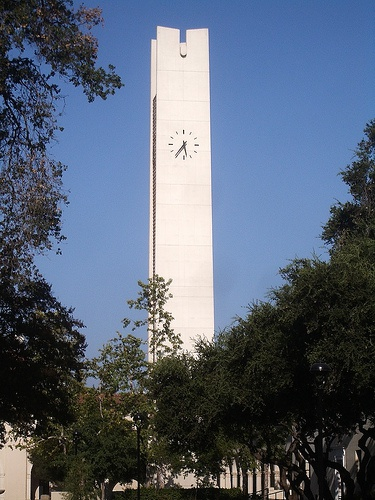Describe the objects in this image and their specific colors. I can see a clock in black, white, darkgray, and gray tones in this image. 